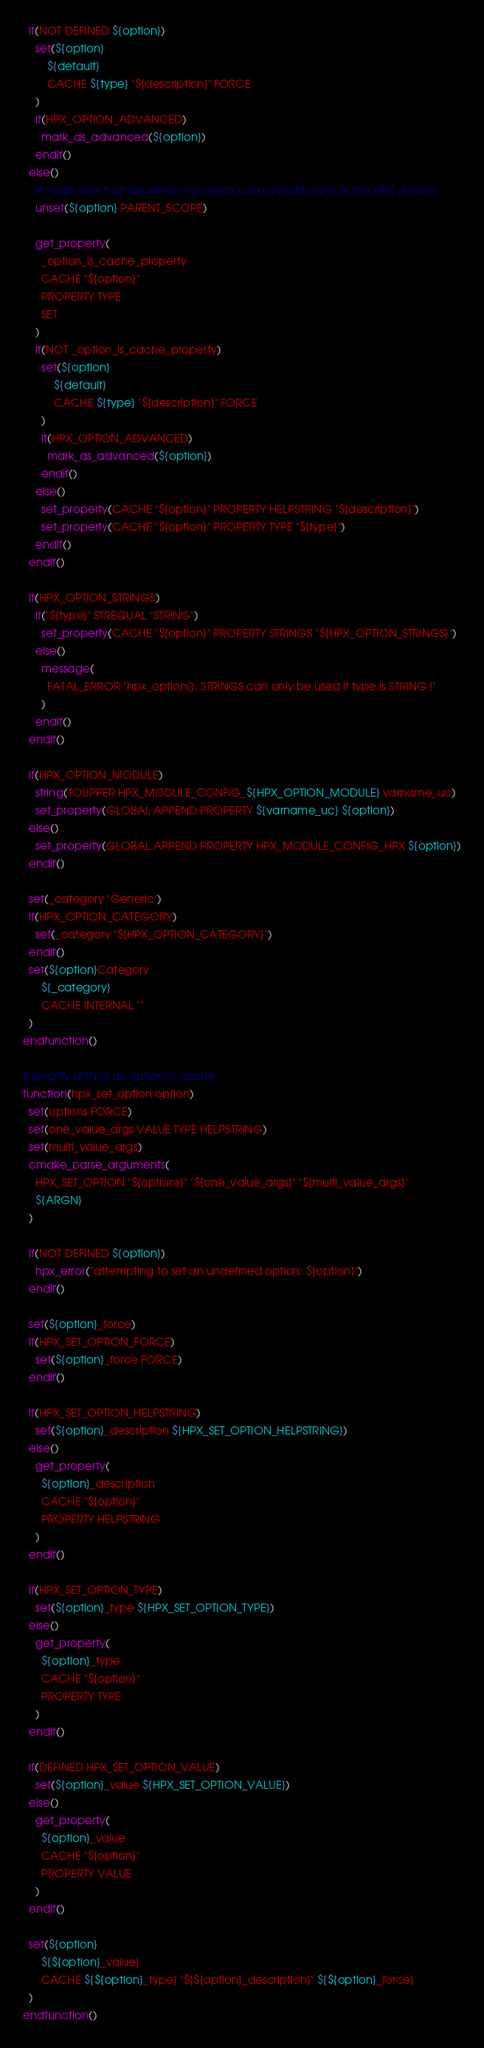Convert code to text. <code><loc_0><loc_0><loc_500><loc_500><_CMake_>
  if(NOT DEFINED ${option})
    set(${option}
        ${default}
        CACHE ${type} "${description}" FORCE
    )
    if(HPX_OPTION_ADVANCED)
      mark_as_advanced(${option})
    endif()
  else()
    # make sure that dependent projects can overwrite any of the HPX options
    unset(${option} PARENT_SCOPE)

    get_property(
      _option_is_cache_property
      CACHE "${option}"
      PROPERTY TYPE
      SET
    )
    if(NOT _option_is_cache_property)
      set(${option}
          ${default}
          CACHE ${type} "${description}" FORCE
      )
      if(HPX_OPTION_ADVANCED)
        mark_as_advanced(${option})
      endif()
    else()
      set_property(CACHE "${option}" PROPERTY HELPSTRING "${description}")
      set_property(CACHE "${option}" PROPERTY TYPE "${type}")
    endif()
  endif()

  if(HPX_OPTION_STRINGS)
    if("${type}" STREQUAL "STRING")
      set_property(CACHE "${option}" PROPERTY STRINGS "${HPX_OPTION_STRINGS}")
    else()
      message(
        FATAL_ERROR "hpx_option(): STRINGS can only be used if type is STRING !"
      )
    endif()
  endif()

  if(HPX_OPTION_MODULE)
    string(TOUPPER HPX_MODULE_CONFIG_${HPX_OPTION_MODULE} varname_uc)
    set_property(GLOBAL APPEND PROPERTY ${varname_uc} ${option})
  else()
    set_property(GLOBAL APPEND PROPERTY HPX_MODULE_CONFIG_HPX ${option})
  endif()

  set(_category "Generic")
  if(HPX_OPTION_CATEGORY)
    set(_category "${HPX_OPTION_CATEGORY}")
  endif()
  set(${option}Category
      ${_category}
      CACHE INTERNAL ""
  )
endfunction()

# simplify setting an option in cache
function(hpx_set_option option)
  set(options FORCE)
  set(one_value_args VALUE TYPE HELPSTRING)
  set(multi_value_args)
  cmake_parse_arguments(
    HPX_SET_OPTION "${options}" "${one_value_args}" "${multi_value_args}"
    ${ARGN}
  )

  if(NOT DEFINED ${option})
    hpx_error("attempting to set an undefined option: ${option}")
  endif()

  set(${option}_force)
  if(HPX_SET_OPTION_FORCE)
    set(${option}_force FORCE)
  endif()

  if(HPX_SET_OPTION_HELPSTRING)
    set(${option}_description ${HPX_SET_OPTION_HELPSTRING})
  else()
    get_property(
      ${option}_description
      CACHE "${option}"
      PROPERTY HELPSTRING
    )
  endif()

  if(HPX_SET_OPTION_TYPE)
    set(${option}_type ${HPX_SET_OPTION_TYPE})
  else()
    get_property(
      ${option}_type
      CACHE "${option}"
      PROPERTY TYPE
    )
  endif()

  if(DEFINED HPX_SET_OPTION_VALUE)
    set(${option}_value ${HPX_SET_OPTION_VALUE})
  else()
    get_property(
      ${option}_value
      CACHE "${option}"
      PROPERTY VALUE
    )
  endif()

  set(${option}
      ${${option}_value}
      CACHE ${${option}_type} "${${option}_description}" ${${option}_force}
  )
endfunction()
</code> 